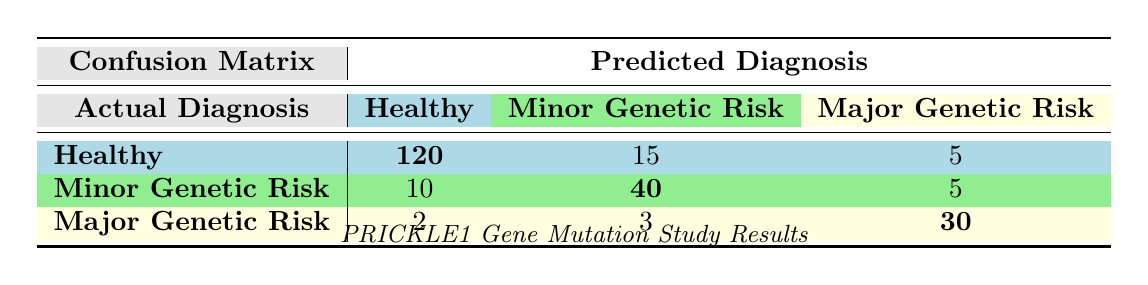What is the count of patients who were correctly predicted as Healthy? The table shows that 120 patients with an actual diagnosis of Healthy were correctly predicted to be Healthy in the confusion matrix.
Answer: 120 How many patients were diagnosed with Major Genetic Risk but incorrectly predicted as Healthy? According to the table, there are 2 patients who had an actual diagnosis of Major Genetic Risk but were predicted as Healthy.
Answer: 2 What is the total number of patients diagnosed with Minor Genetic Risk? To find this, we look at both the predicted and actual values for Minor Genetic Risk. The counts are 10 (predicted as Healthy), 40 (predicted as Minor Genetic Risk), and 5 (predicted as Major Genetic Risk), so the total is 10 + 40 + 5 = 55.
Answer: 55 Is the number of patients correctly predicted with Major Genetic Risk greater than those correctly predicted with Minor Genetic Risk? The table shows that 30 patients were correctly predicted as Major Genetic Risk, while 40 were correctly predicted as Minor Genetic Risk. Since 30 is less than 40, the statement is false.
Answer: No What percentage of patients with an actual diagnosis of Healthy were predicted as Minor Genetic Risk? The total number of patients with an actual diagnosis of Healthy is 120 + 15 + 5 = 140. The number predicted as Minor Genetic Risk is 15, so the percentage is (15 / 140) * 100 = 10.71%.
Answer: 10.71% What is the total count of patients who were incorrectly predicted as having Major Genetic Risk? The table indicates that 5 patients with an actual diagnosis of Minor Genetic Risk were predicted as Major Genetic Risk, and 3 patients with Major Genetic Risk were predicted as Minor Genetic Risk. Thus, the total is 5 + 3 = 8.
Answer: 8 How many patients were diagnosed as Healthy and also predicted as Major Genetic Risk? The confusion matrix shows that 5 patients who were actually diagnosed as Healthy were predicted as having Major Genetic Risk.
Answer: 5 What is the combined total of patients accurately identified as Healthy and predicted as Minor Genetic Risk? The number of healthy patients accurately predicted is 120, and those incorrectly predicted as Minor Genetic Risk is 15, thus the combined total is 120 + 15 = 135.
Answer: 135 